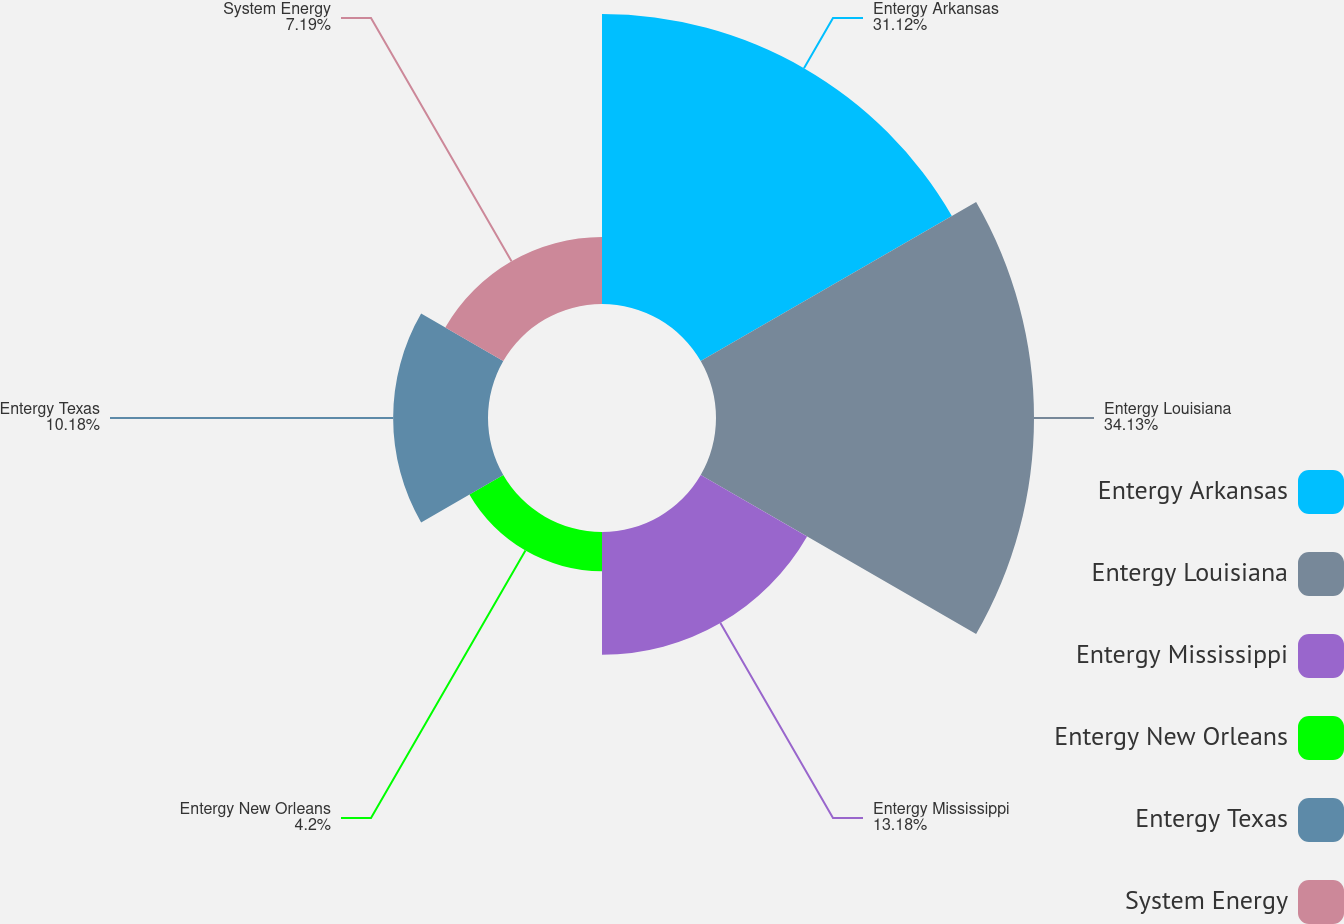<chart> <loc_0><loc_0><loc_500><loc_500><pie_chart><fcel>Entergy Arkansas<fcel>Entergy Louisiana<fcel>Entergy Mississippi<fcel>Entergy New Orleans<fcel>Entergy Texas<fcel>System Energy<nl><fcel>31.12%<fcel>34.13%<fcel>13.18%<fcel>4.2%<fcel>10.18%<fcel>7.19%<nl></chart> 